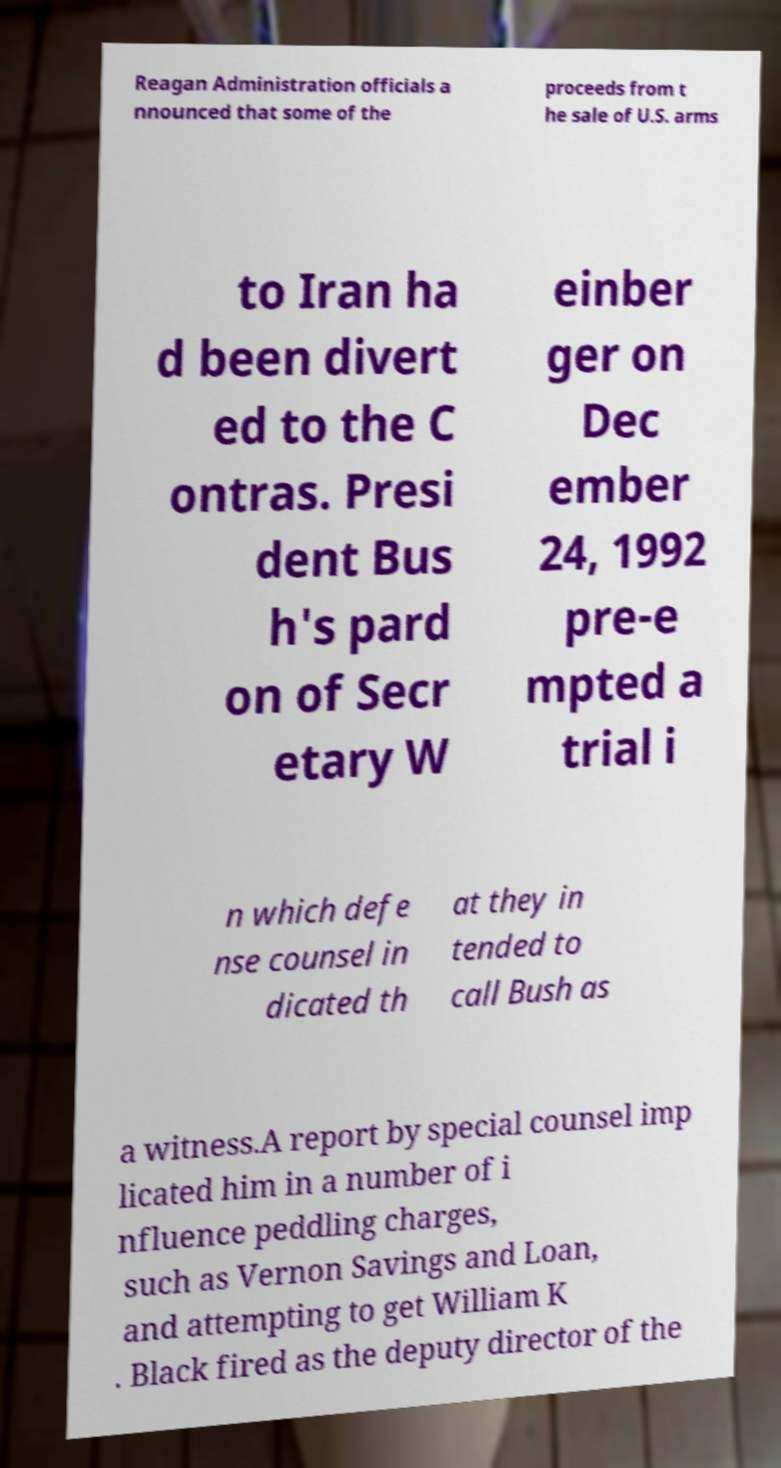There's text embedded in this image that I need extracted. Can you transcribe it verbatim? Reagan Administration officials a nnounced that some of the proceeds from t he sale of U.S. arms to Iran ha d been divert ed to the C ontras. Presi dent Bus h's pard on of Secr etary W einber ger on Dec ember 24, 1992 pre-e mpted a trial i n which defe nse counsel in dicated th at they in tended to call Bush as a witness.A report by special counsel imp licated him in a number of i nfluence peddling charges, such as Vernon Savings and Loan, and attempting to get William K . Black fired as the deputy director of the 